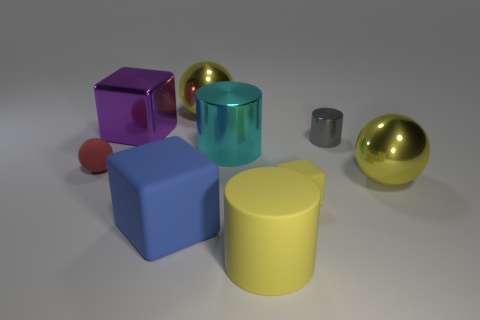Add 1 tiny red things. How many objects exist? 10 Subtract all balls. How many objects are left? 6 Subtract all large cyan metallic balls. Subtract all large yellow cylinders. How many objects are left? 8 Add 3 purple blocks. How many purple blocks are left? 4 Add 7 small purple rubber cubes. How many small purple rubber cubes exist? 7 Subtract 0 blue cylinders. How many objects are left? 9 